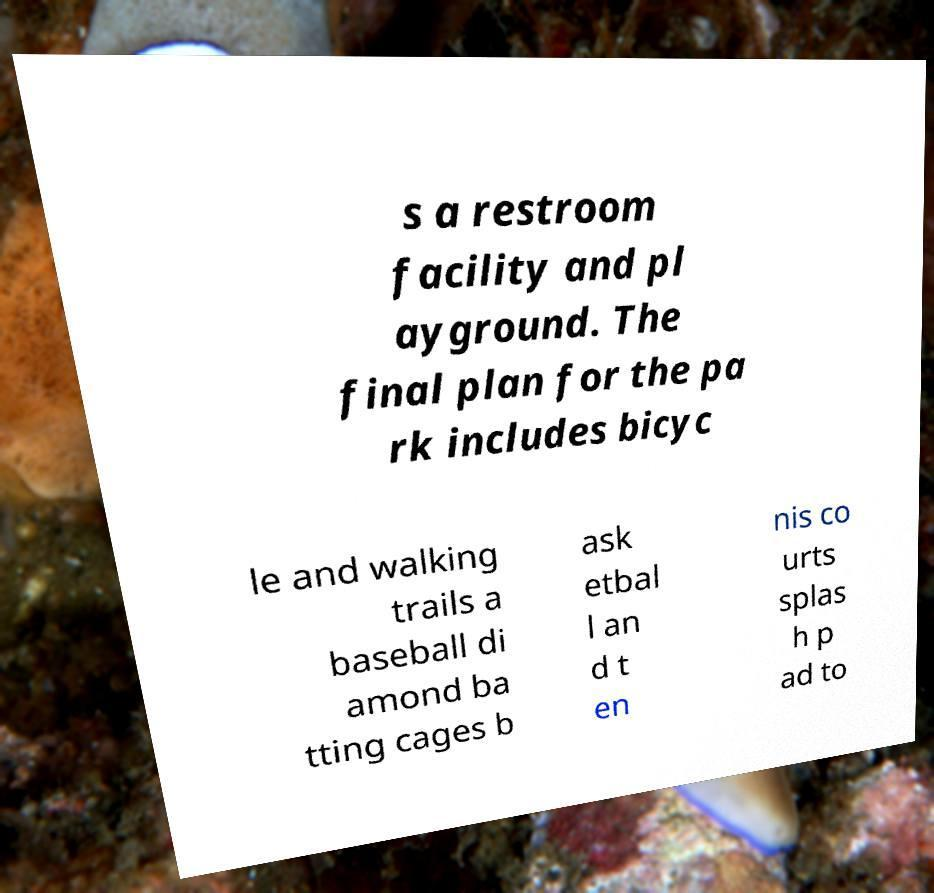Can you read and provide the text displayed in the image?This photo seems to have some interesting text. Can you extract and type it out for me? s a restroom facility and pl ayground. The final plan for the pa rk includes bicyc le and walking trails a baseball di amond ba tting cages b ask etbal l an d t en nis co urts splas h p ad to 